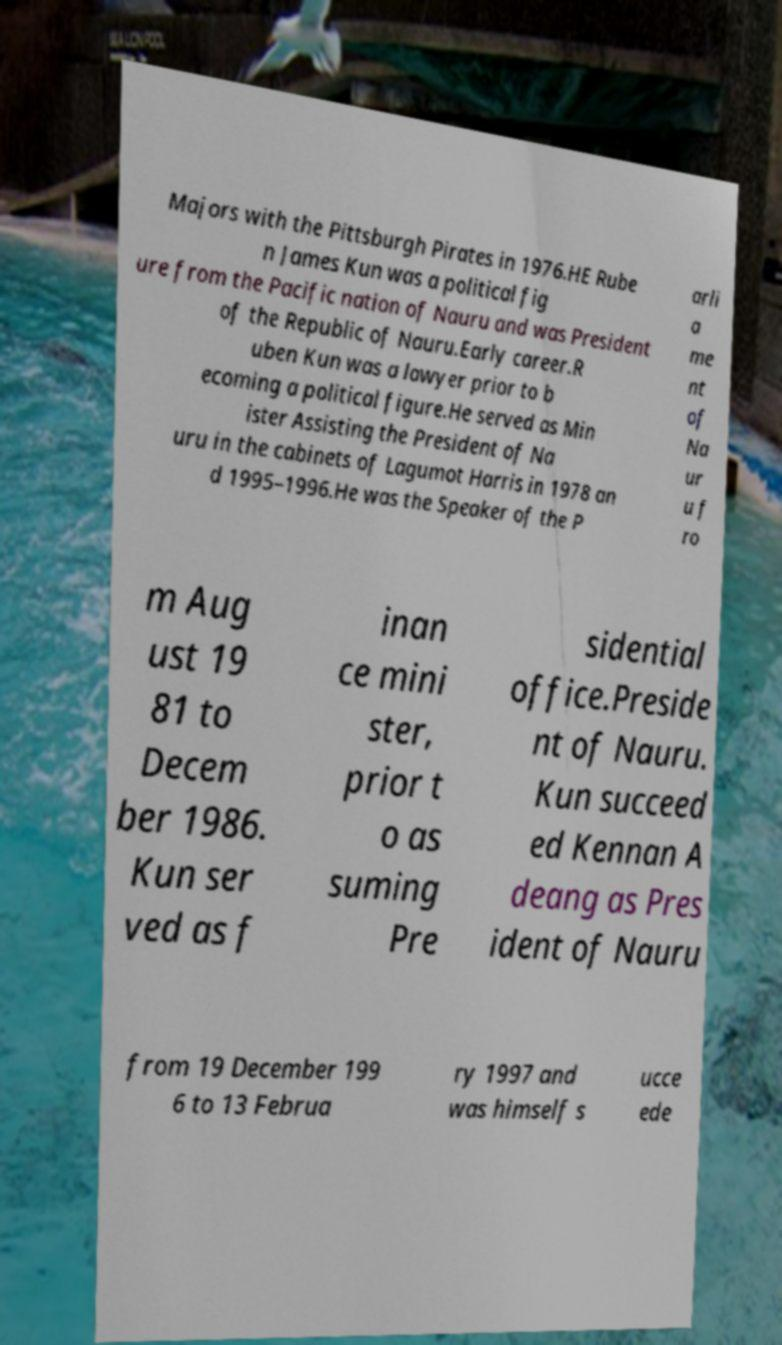There's text embedded in this image that I need extracted. Can you transcribe it verbatim? Majors with the Pittsburgh Pirates in 1976.HE Rube n James Kun was a political fig ure from the Pacific nation of Nauru and was President of the Republic of Nauru.Early career.R uben Kun was a lawyer prior to b ecoming a political figure.He served as Min ister Assisting the President of Na uru in the cabinets of Lagumot Harris in 1978 an d 1995–1996.He was the Speaker of the P arli a me nt of Na ur u f ro m Aug ust 19 81 to Decem ber 1986. Kun ser ved as f inan ce mini ster, prior t o as suming Pre sidential office.Preside nt of Nauru. Kun succeed ed Kennan A deang as Pres ident of Nauru from 19 December 199 6 to 13 Februa ry 1997 and was himself s ucce ede 